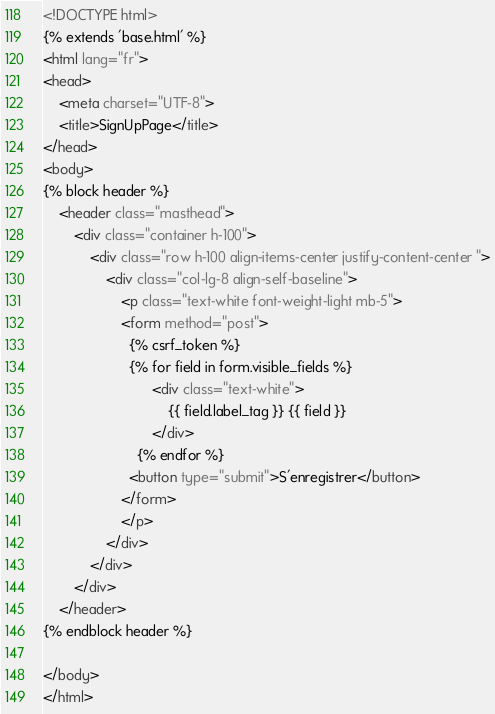Convert code to text. <code><loc_0><loc_0><loc_500><loc_500><_HTML_><!DOCTYPE html>
{% extends 'base.html' %}
<html lang="fr">
<head>
    <meta charset="UTF-8">
    <title>SignUpPage</title>
</head>
<body>
{% block header %}
    <header class="masthead">
        <div class="container h-100">
            <div class="row h-100 align-items-center justify-content-center ">
                <div class="col-lg-8 align-self-baseline">
                    <p class="text-white font-weight-light mb-5">
                    <form method="post">
                      {% csrf_token %}
                      {% for field in form.visible_fields %}
                            <div class="text-white">
                                {{ field.label_tag }} {{ field }}
                            </div>
                        {% endfor %}
                      <button type="submit">S'enregistrer</button>
                    </form>
                    </p>
                </div>
            </div>
        </div>
    </header>
{% endblock header %}

</body>
</html></code> 